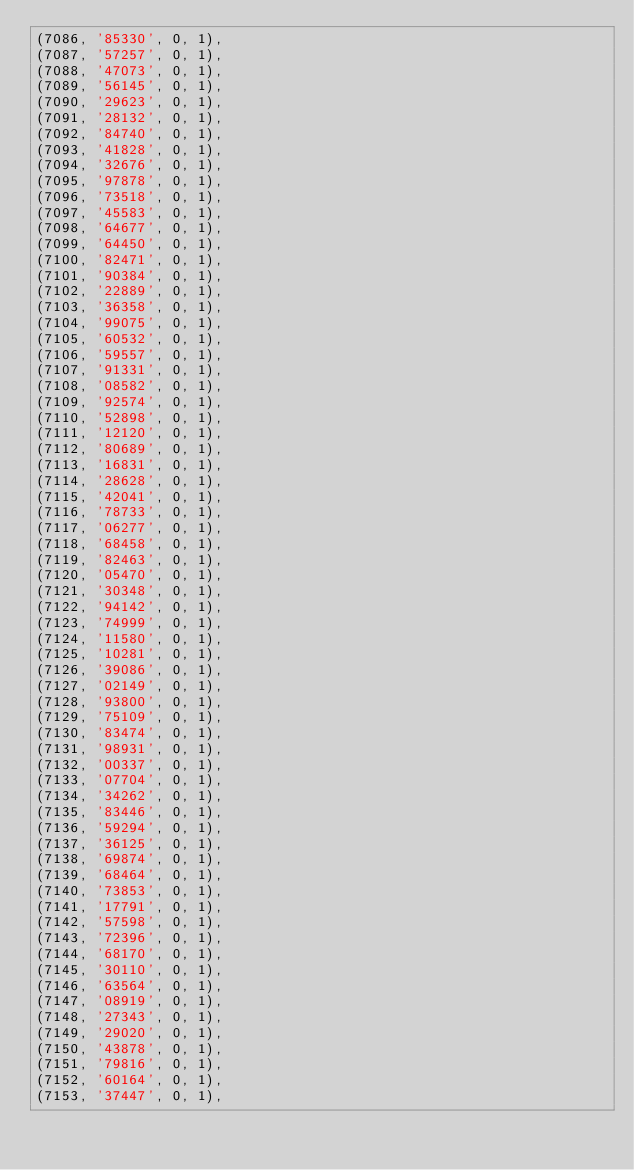<code> <loc_0><loc_0><loc_500><loc_500><_SQL_>(7086, '85330', 0, 1),
(7087, '57257', 0, 1),
(7088, '47073', 0, 1),
(7089, '56145', 0, 1),
(7090, '29623', 0, 1),
(7091, '28132', 0, 1),
(7092, '84740', 0, 1),
(7093, '41828', 0, 1),
(7094, '32676', 0, 1),
(7095, '97878', 0, 1),
(7096, '73518', 0, 1),
(7097, '45583', 0, 1),
(7098, '64677', 0, 1),
(7099, '64450', 0, 1),
(7100, '82471', 0, 1),
(7101, '90384', 0, 1),
(7102, '22889', 0, 1),
(7103, '36358', 0, 1),
(7104, '99075', 0, 1),
(7105, '60532', 0, 1),
(7106, '59557', 0, 1),
(7107, '91331', 0, 1),
(7108, '08582', 0, 1),
(7109, '92574', 0, 1),
(7110, '52898', 0, 1),
(7111, '12120', 0, 1),
(7112, '80689', 0, 1),
(7113, '16831', 0, 1),
(7114, '28628', 0, 1),
(7115, '42041', 0, 1),
(7116, '78733', 0, 1),
(7117, '06277', 0, 1),
(7118, '68458', 0, 1),
(7119, '82463', 0, 1),
(7120, '05470', 0, 1),
(7121, '30348', 0, 1),
(7122, '94142', 0, 1),
(7123, '74999', 0, 1),
(7124, '11580', 0, 1),
(7125, '10281', 0, 1),
(7126, '39086', 0, 1),
(7127, '02149', 0, 1),
(7128, '93800', 0, 1),
(7129, '75109', 0, 1),
(7130, '83474', 0, 1),
(7131, '98931', 0, 1),
(7132, '00337', 0, 1),
(7133, '07704', 0, 1),
(7134, '34262', 0, 1),
(7135, '83446', 0, 1),
(7136, '59294', 0, 1),
(7137, '36125', 0, 1),
(7138, '69874', 0, 1),
(7139, '68464', 0, 1),
(7140, '73853', 0, 1),
(7141, '17791', 0, 1),
(7142, '57598', 0, 1),
(7143, '72396', 0, 1),
(7144, '68170', 0, 1),
(7145, '30110', 0, 1),
(7146, '63564', 0, 1),
(7147, '08919', 0, 1),
(7148, '27343', 0, 1),
(7149, '29020', 0, 1),
(7150, '43878', 0, 1),
(7151, '79816', 0, 1),
(7152, '60164', 0, 1),
(7153, '37447', 0, 1),</code> 